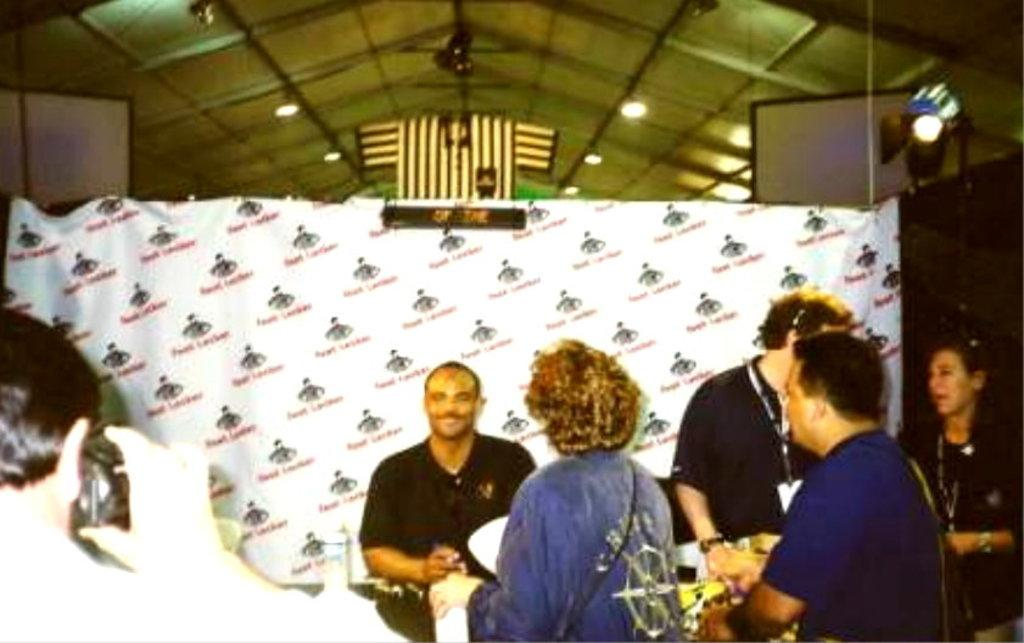How many people are in the image? There is a group of people in the image, but the exact number cannot be determined from the provided facts. What is the person holding in the image? The person is holding a camera in the image. What can be seen on the banner in the image? The content of the banner cannot be determined from the provided facts. What type of lighting is present in the image? There are lights in the image, but the specific type of lighting cannot be determined from the provided facts. Can you describe any other objects in the image? There are other objects in the image, but their specific nature cannot be determined from the provided facts. What brand of toothpaste is being used by the person in the image? There is no toothpaste present in the image, so it is not possible to determine which brand might be used. 